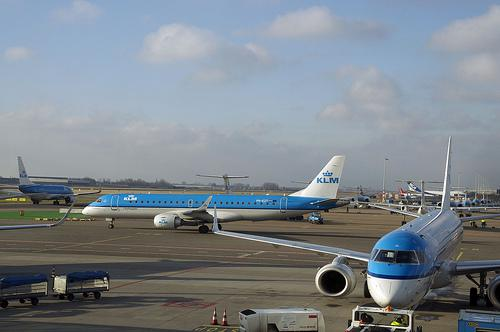Question: why do people fly in airplanes?
Choices:
A. Fun.
B. Necessity.
C. For work.
D. Travel.
Answer with the letter. Answer: D Question: where do airplanes fly?
Choices:
A. All over the world.
B. To Omaha.
C. To Tokyo.
D. To England.
Answer with the letter. Answer: A Question: what are the letters on the plane?
Choices:
A. KLM.
B. Abc.
C. Kjm.
D. Mjl.
Answer with the letter. Answer: A Question: what is in the sky?
Choices:
A. Birds.
B. Bugs.
C. Planes.
D. Clouds.
Answer with the letter. Answer: D 